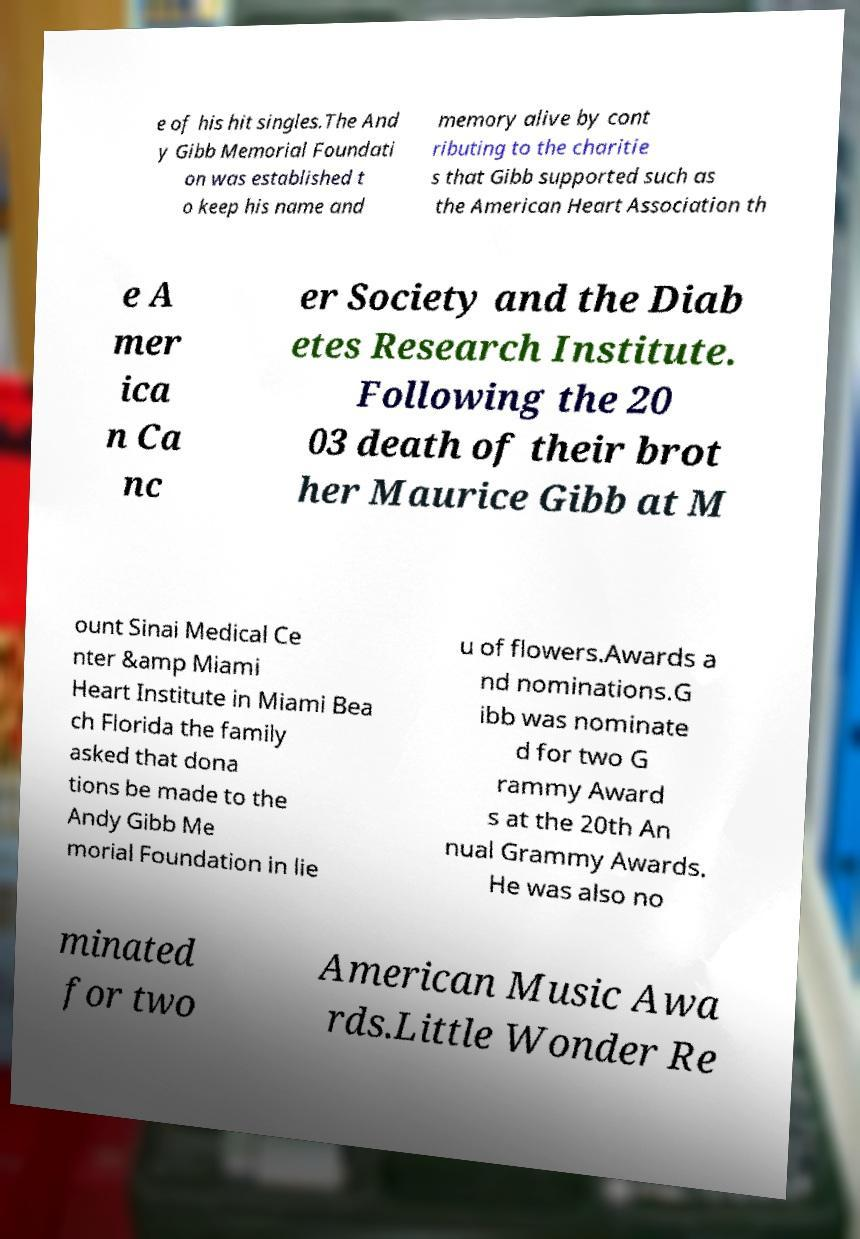There's text embedded in this image that I need extracted. Can you transcribe it verbatim? e of his hit singles.The And y Gibb Memorial Foundati on was established t o keep his name and memory alive by cont ributing to the charitie s that Gibb supported such as the American Heart Association th e A mer ica n Ca nc er Society and the Diab etes Research Institute. Following the 20 03 death of their brot her Maurice Gibb at M ount Sinai Medical Ce nter &amp Miami Heart Institute in Miami Bea ch Florida the family asked that dona tions be made to the Andy Gibb Me morial Foundation in lie u of flowers.Awards a nd nominations.G ibb was nominate d for two G rammy Award s at the 20th An nual Grammy Awards. He was also no minated for two American Music Awa rds.Little Wonder Re 